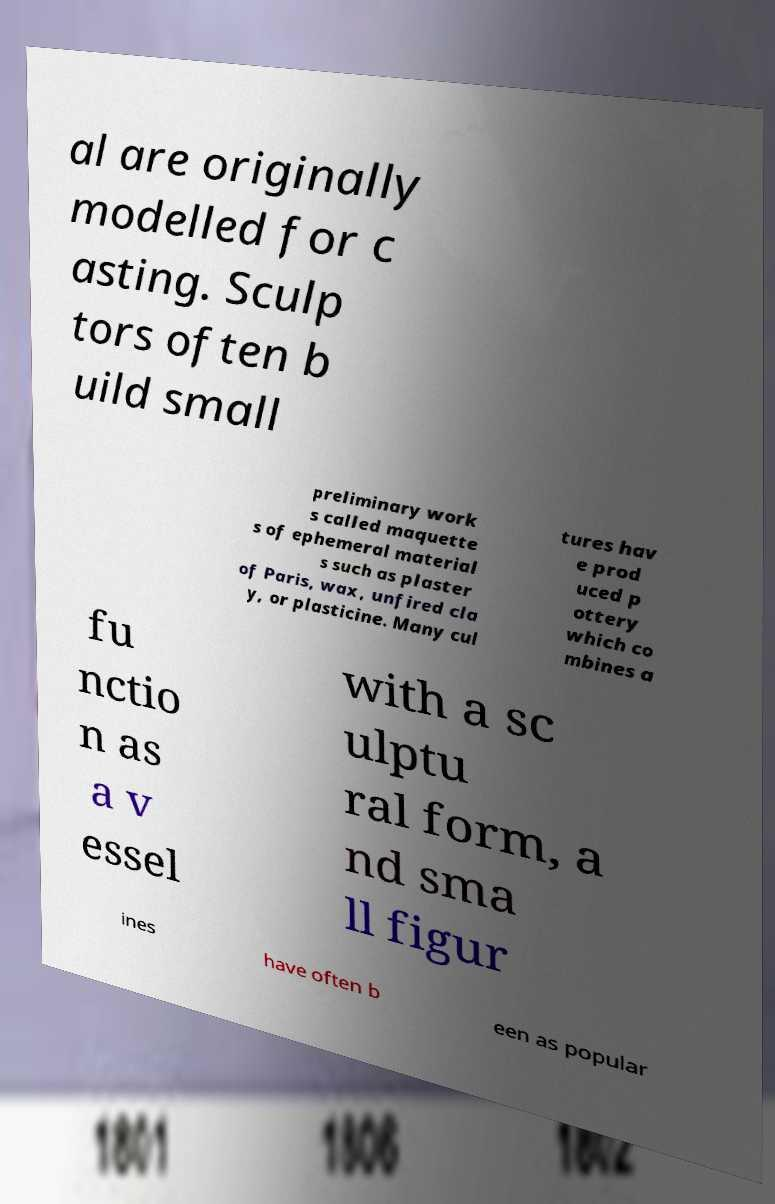Could you assist in decoding the text presented in this image and type it out clearly? al are originally modelled for c asting. Sculp tors often b uild small preliminary work s called maquette s of ephemeral material s such as plaster of Paris, wax, unfired cla y, or plasticine. Many cul tures hav e prod uced p ottery which co mbines a fu nctio n as a v essel with a sc ulptu ral form, a nd sma ll figur ines have often b een as popular 